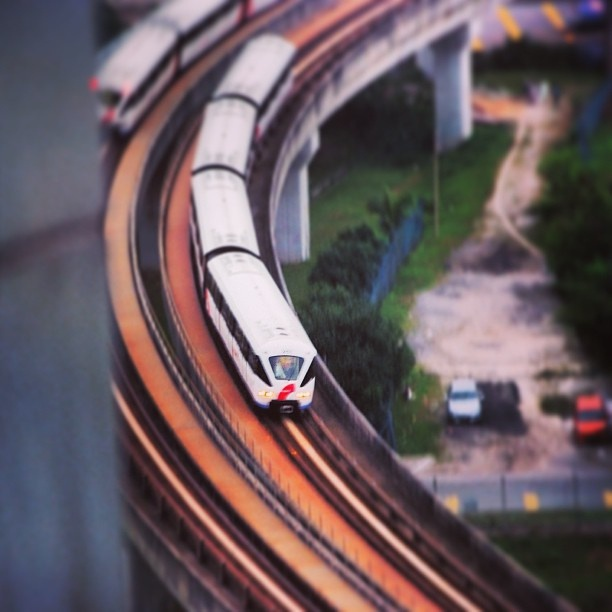Describe the objects in this image and their specific colors. I can see train in black, lightgray, purple, and darkgray tones, train in black, gray, darkgray, and lightgray tones, car in black, maroon, purple, and salmon tones, and car in black, lavender, darkgray, and gray tones in this image. 